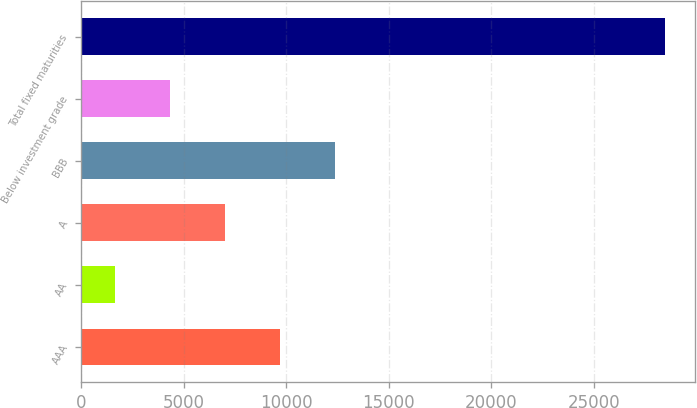Convert chart. <chart><loc_0><loc_0><loc_500><loc_500><bar_chart><fcel>AAA<fcel>AA<fcel>A<fcel>BBB<fcel>Below investment grade<fcel>Total fixed maturities<nl><fcel>9684.9<fcel>1620<fcel>6996.6<fcel>12373.2<fcel>4308.3<fcel>28503<nl></chart> 